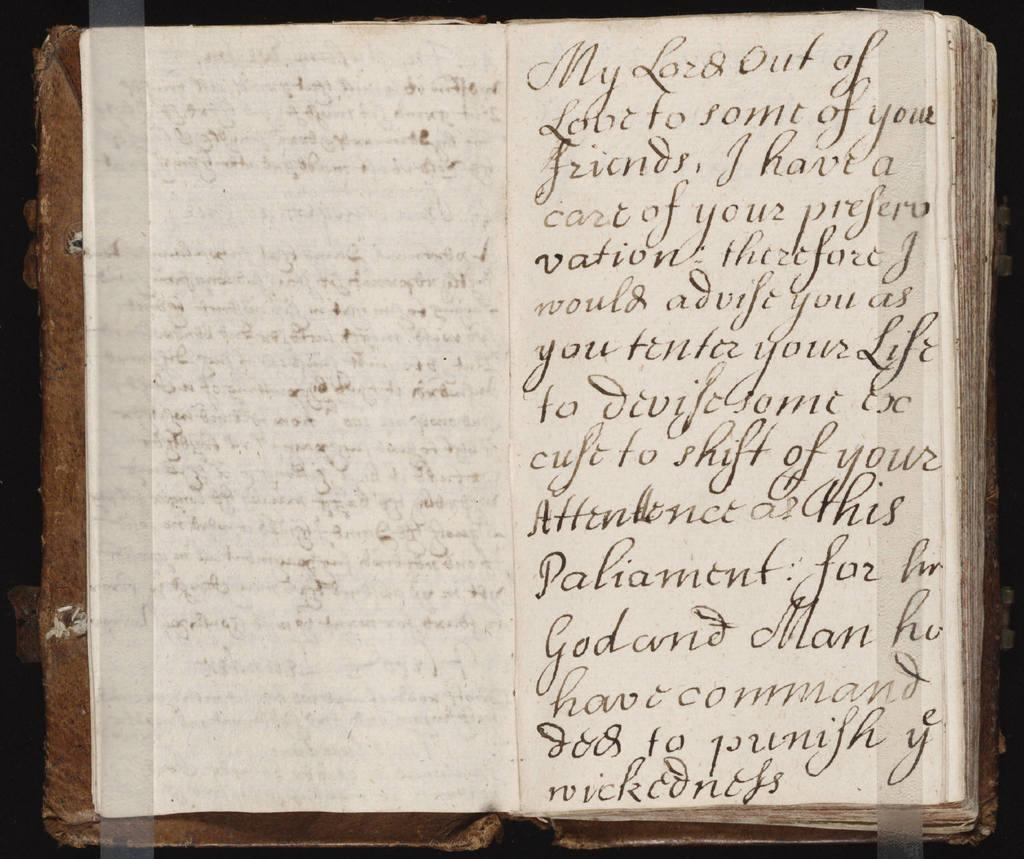<image>
Offer a succinct explanation of the picture presented. An open book that begins with "My Lord out of love for some of your friends" 